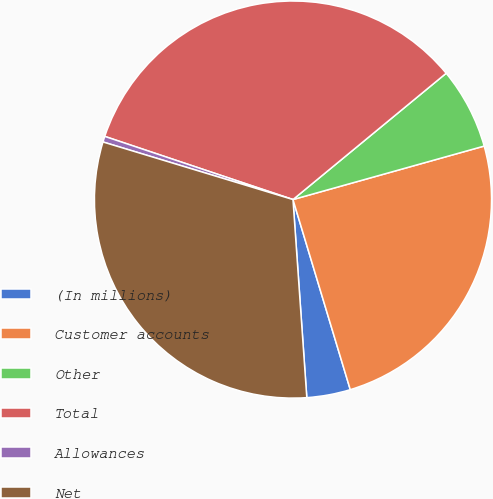<chart> <loc_0><loc_0><loc_500><loc_500><pie_chart><fcel>(In millions)<fcel>Customer accounts<fcel>Other<fcel>Total<fcel>Allowances<fcel>Net<nl><fcel>3.55%<fcel>24.68%<fcel>6.63%<fcel>33.87%<fcel>0.47%<fcel>30.79%<nl></chart> 